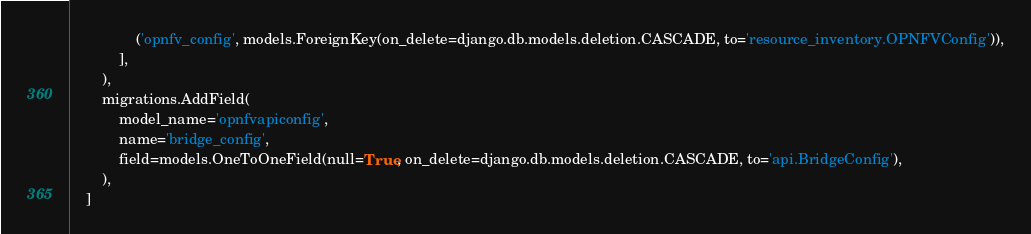<code> <loc_0><loc_0><loc_500><loc_500><_Python_>                ('opnfv_config', models.ForeignKey(on_delete=django.db.models.deletion.CASCADE, to='resource_inventory.OPNFVConfig')),
            ],
        ),
        migrations.AddField(
            model_name='opnfvapiconfig',
            name='bridge_config',
            field=models.OneToOneField(null=True, on_delete=django.db.models.deletion.CASCADE, to='api.BridgeConfig'),
        ),
    ]
</code> 